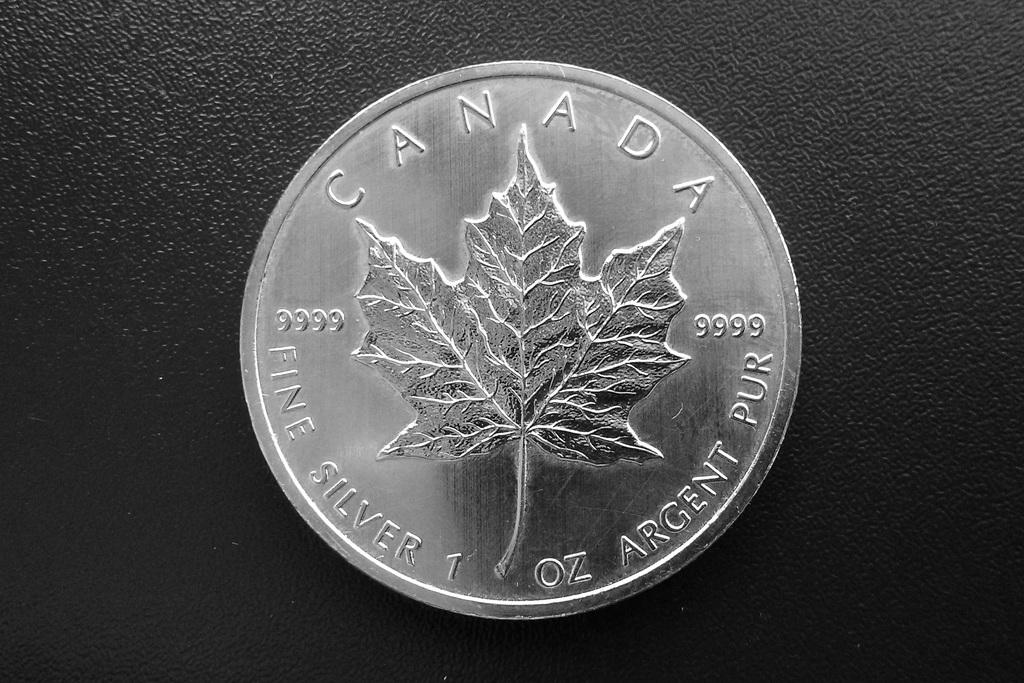<image>
Render a clear and concise summary of the photo. A one ounce silver coin that is from the country of Canada. 